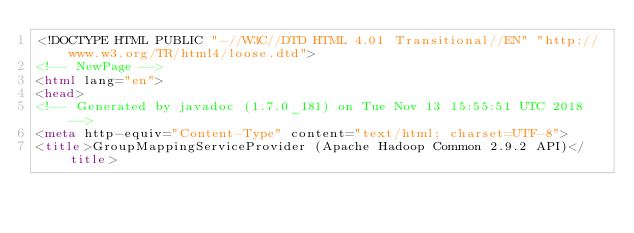Convert code to text. <code><loc_0><loc_0><loc_500><loc_500><_HTML_><!DOCTYPE HTML PUBLIC "-//W3C//DTD HTML 4.01 Transitional//EN" "http://www.w3.org/TR/html4/loose.dtd">
<!-- NewPage -->
<html lang="en">
<head>
<!-- Generated by javadoc (1.7.0_181) on Tue Nov 13 15:55:51 UTC 2018 -->
<meta http-equiv="Content-Type" content="text/html; charset=UTF-8">
<title>GroupMappingServiceProvider (Apache Hadoop Common 2.9.2 API)</title></code> 